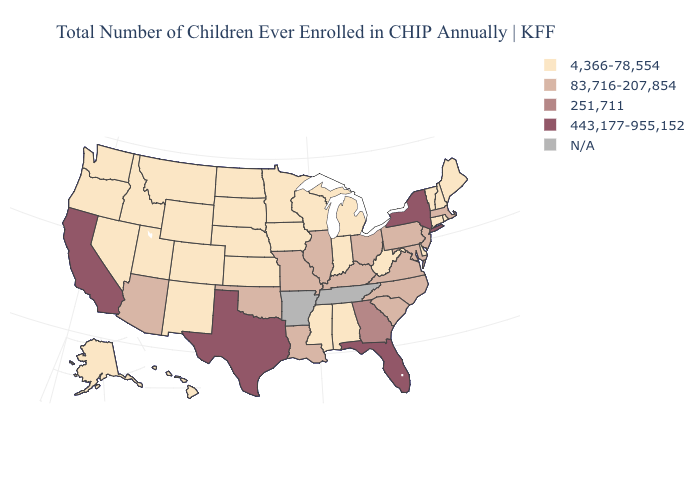Is the legend a continuous bar?
Short answer required. No. What is the value of Mississippi?
Short answer required. 4,366-78,554. What is the lowest value in the Northeast?
Give a very brief answer. 4,366-78,554. What is the value of South Carolina?
Answer briefly. 83,716-207,854. Among the states that border South Carolina , which have the highest value?
Keep it brief. Georgia. What is the value of Washington?
Write a very short answer. 4,366-78,554. What is the value of Texas?
Answer briefly. 443,177-955,152. Among the states that border Oklahoma , does Kansas have the highest value?
Answer briefly. No. Which states have the highest value in the USA?
Short answer required. California, Florida, New York, Texas. What is the value of Massachusetts?
Give a very brief answer. 83,716-207,854. Does Texas have the highest value in the USA?
Write a very short answer. Yes. What is the value of Montana?
Write a very short answer. 4,366-78,554. Does Missouri have the lowest value in the USA?
Give a very brief answer. No. Does Virginia have the lowest value in the USA?
Short answer required. No. Does Missouri have the highest value in the MidWest?
Keep it brief. Yes. 